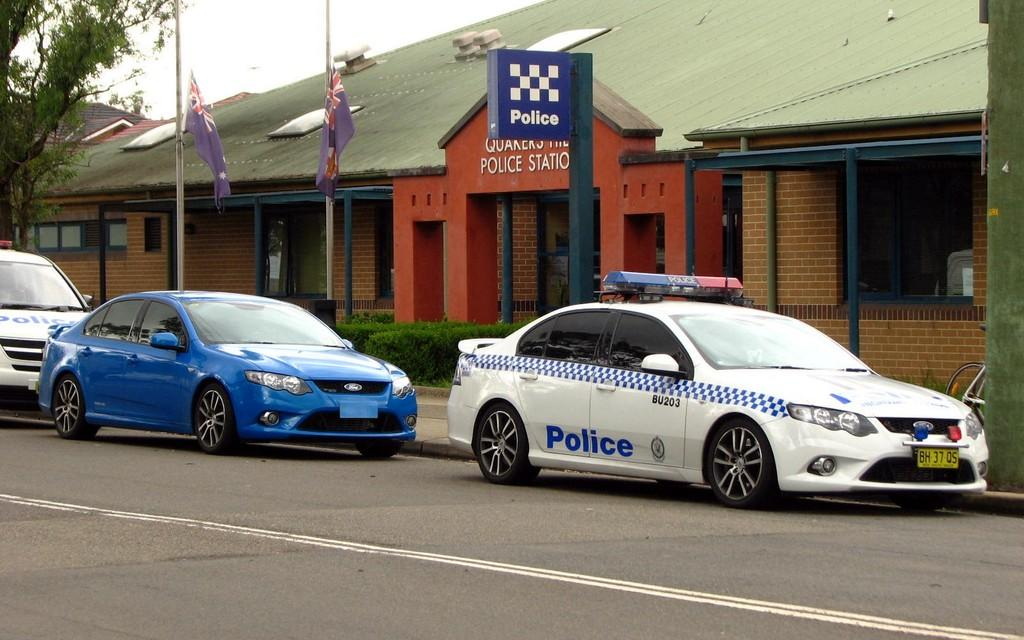How many cars are visible on the road in the image? There are three cars on the road in the image. What is the time of day when the image was taken? The image was taken during the day. What type of guitar is being played at the dinner table in the image? There is no guitar or dinner table present in the image. What type of iron is visible in the image? There is no iron visible in the image. 